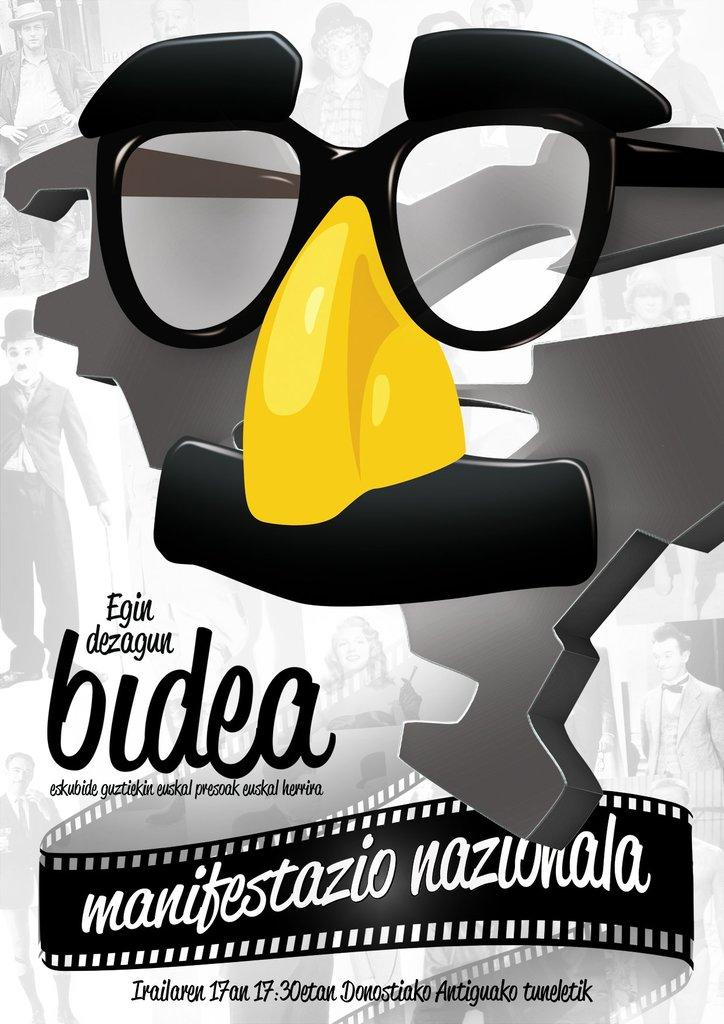What is the main object in the image that resembles a mask? There is a mask-like thing in the image. Is there any text present in the image? Yes, there is writing on the bottom side of the image. What else can be seen in the image besides the mask-like object and the writing? There are pictures of people in the image. What does your aunt say about the mask-like object in the image? There is no mention of an aunt or any personal opinions in the image, so it is not possible to answer that question. 